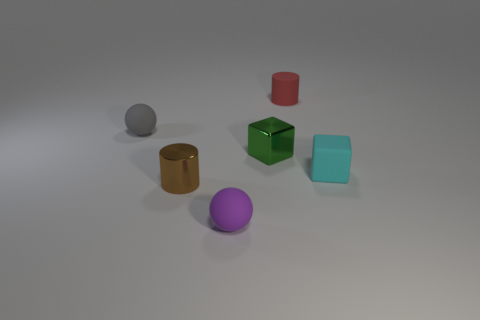There is a tiny thing that is in front of the brown cylinder; is it the same shape as the red thing?
Ensure brevity in your answer.  No. What number of things are small brown metal things or metallic things left of the tiny purple rubber thing?
Offer a terse response. 1. Do the small sphere behind the green shiny thing and the tiny purple object have the same material?
Provide a succinct answer. Yes. The block behind the cyan matte object in front of the green block is made of what material?
Your answer should be very brief. Metal. Is the number of small metallic things that are in front of the small green metallic block greater than the number of tiny brown metallic objects behind the tiny gray rubber thing?
Provide a short and direct response. Yes. What size is the red rubber object?
Keep it short and to the point. Small. Is there anything else that has the same shape as the tiny green metallic object?
Provide a succinct answer. Yes. There is a tiny ball that is behind the purple thing; is there a brown thing that is in front of it?
Give a very brief answer. Yes. Are there fewer purple spheres that are in front of the purple sphere than small matte objects that are behind the small gray matte object?
Keep it short and to the point. Yes. There is a metallic object that is on the right side of the small thing that is in front of the cylinder in front of the small metallic block; how big is it?
Offer a terse response. Small. 